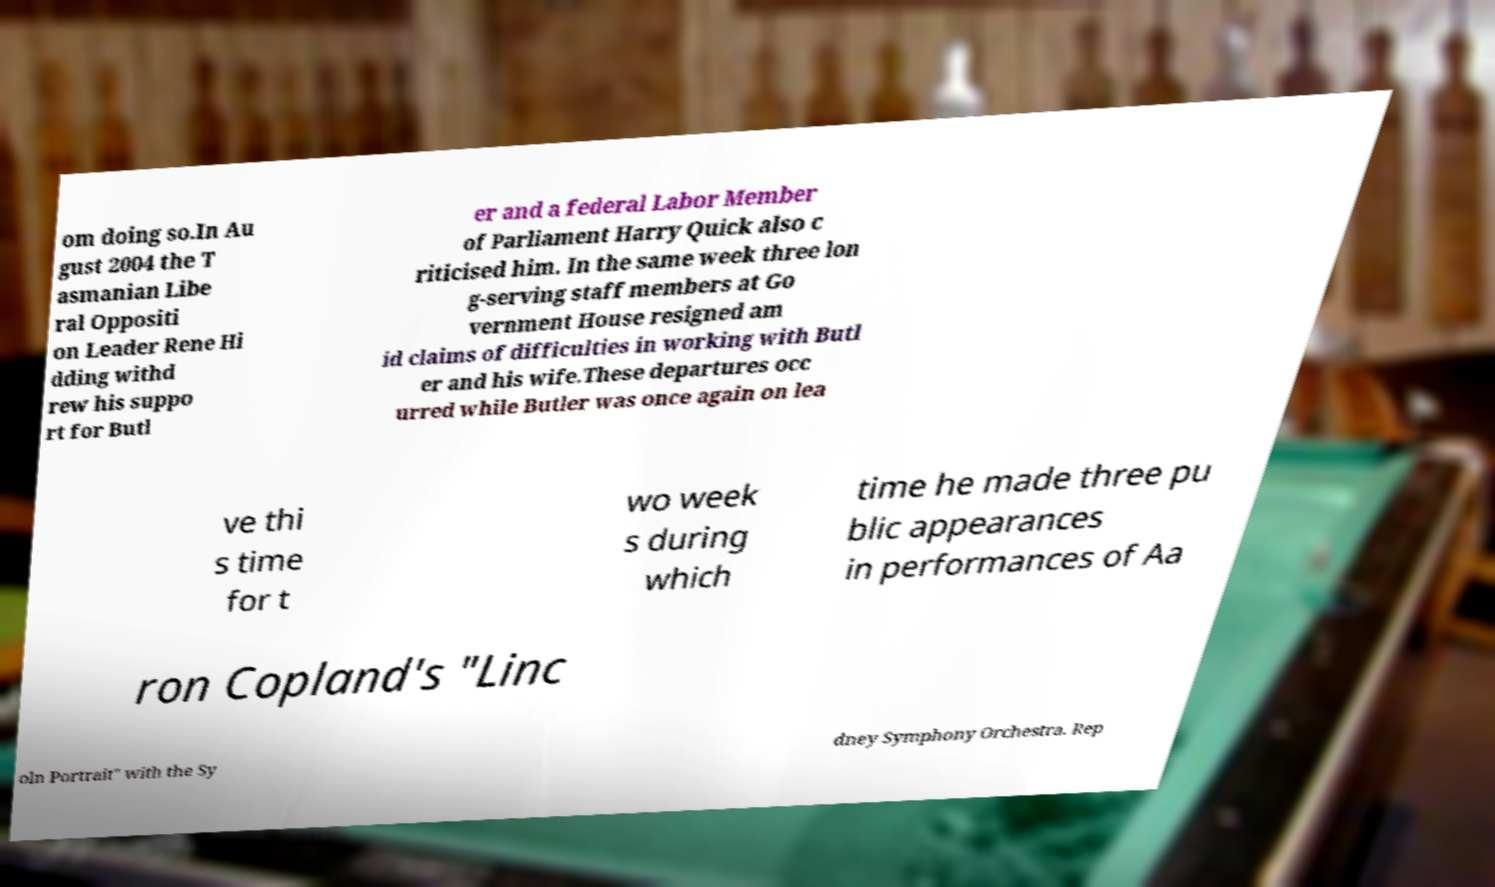Please read and relay the text visible in this image. What does it say? om doing so.In Au gust 2004 the T asmanian Libe ral Oppositi on Leader Rene Hi dding withd rew his suppo rt for Butl er and a federal Labor Member of Parliament Harry Quick also c riticised him. In the same week three lon g-serving staff members at Go vernment House resigned am id claims of difficulties in working with Butl er and his wife.These departures occ urred while Butler was once again on lea ve thi s time for t wo week s during which time he made three pu blic appearances in performances of Aa ron Copland's "Linc oln Portrait" with the Sy dney Symphony Orchestra. Rep 